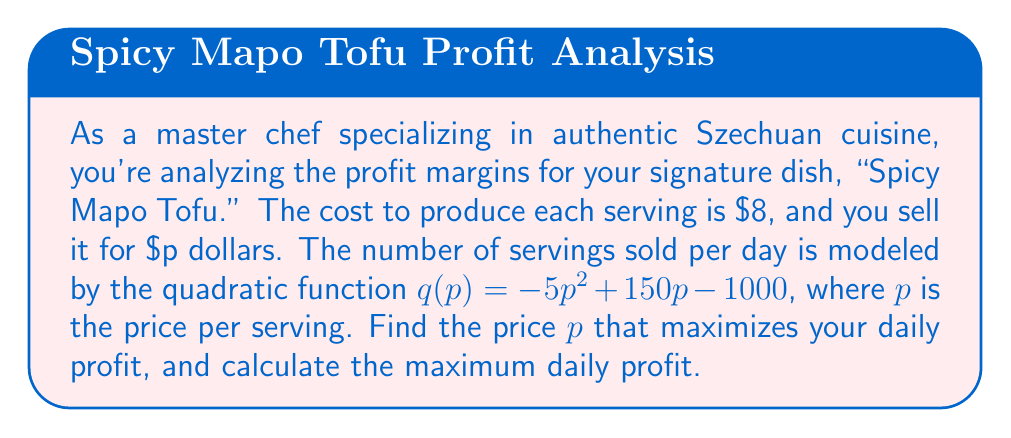Teach me how to tackle this problem. Let's approach this step-by-step:

1) First, we need to formulate the profit function. Profit is revenue minus cost.
   Revenue = Price per unit × Number of units sold
   Cost = Cost per unit × Number of units sold
   
   Profit function: $P(p) = pq(p) - 8q(p)$
   
2) Substitute $q(p) = -5p^2 + 150p - 1000$:
   $P(p) = p(-5p^2 + 150p - 1000) - 8(-5p^2 + 150p - 1000)$
   
3) Expand the equation:
   $P(p) = -5p^3 + 150p^2 - 1000p + 40p^2 - 1200p + 8000$
   $P(p) = -5p^3 + 190p^2 - 2200p + 8000$

4) To find the maximum profit, we need to find where the derivative of $P(p)$ equals zero:
   $P'(p) = -15p^2 + 380p - 2200$

5) Set $P'(p) = 0$ and solve:
   $-15p^2 + 380p - 2200 = 0$
   
6) This is a quadratic equation. We can solve it using the quadratic formula:
   $p = \frac{-b \pm \sqrt{b^2 - 4ac}}{2a}$
   
   Where $a = -15$, $b = 380$, and $c = -2200$

7) Plugging in these values:
   $p = \frac{-380 \pm \sqrt{380^2 - 4(-15)(-2200)}}{2(-15)}$
   $= \frac{-380 \pm \sqrt{144400 - 132000}}{-30}$
   $= \frac{-380 \pm \sqrt{12400}}{-30}$
   $= \frac{-380 \pm 111.36}{-30}$

8) This gives us two solutions:
   $p_1 = \frac{-380 + 111.36}{-30} \approx 8.95$
   $p_2 = \frac{-380 - 111.36}{-30} \approx 16.38$

9) The second derivative of $P(p)$ is $P''(p) = -30p + 380$. At $p = 8.95$, $P''(8.95) > 0$, indicating a local minimum. At $p = 16.38$, $P''(16.38) < 0$, indicating a local maximum.

10) Therefore, the price that maximizes profit is approximately $16.38.

11) To find the maximum profit, we substitute this price back into our original profit function:
    $P(16.38) = -5(16.38)^3 + 190(16.38)^2 - 2200(16.38) + 8000 \approx 3267.57$
Answer: The price that maximizes daily profit is approximately $16.38 per serving, and the maximum daily profit is approximately $3267.57. 